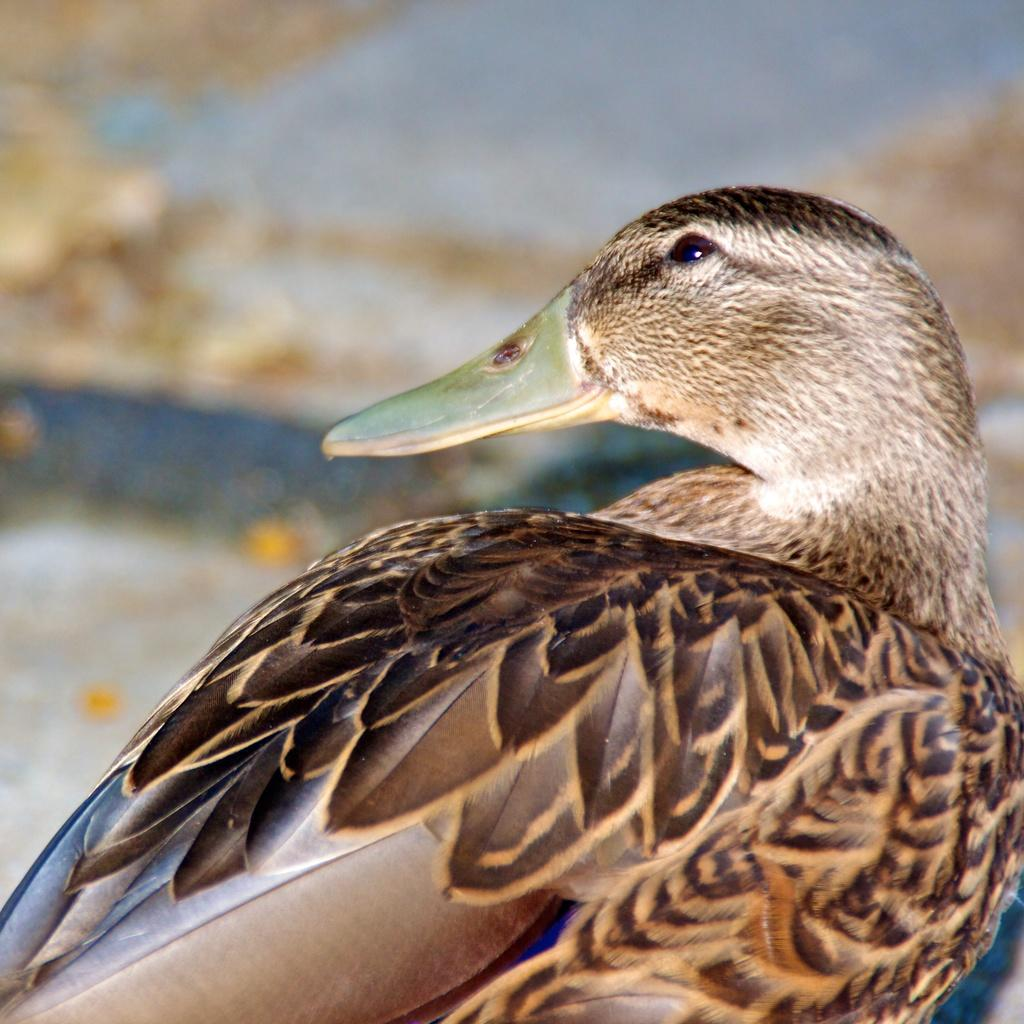What type of animal is present in the image? There is a bird in the image. Can you describe the background of the image? The background of the image is blurred. What type of expert advice can be seen in the image? There is no expert advice present in the image; it features a bird and a blurred background. What type of vegetation can be seen growing in the image? There is no vegetation present in the image; it features a bird and a blurred background. 